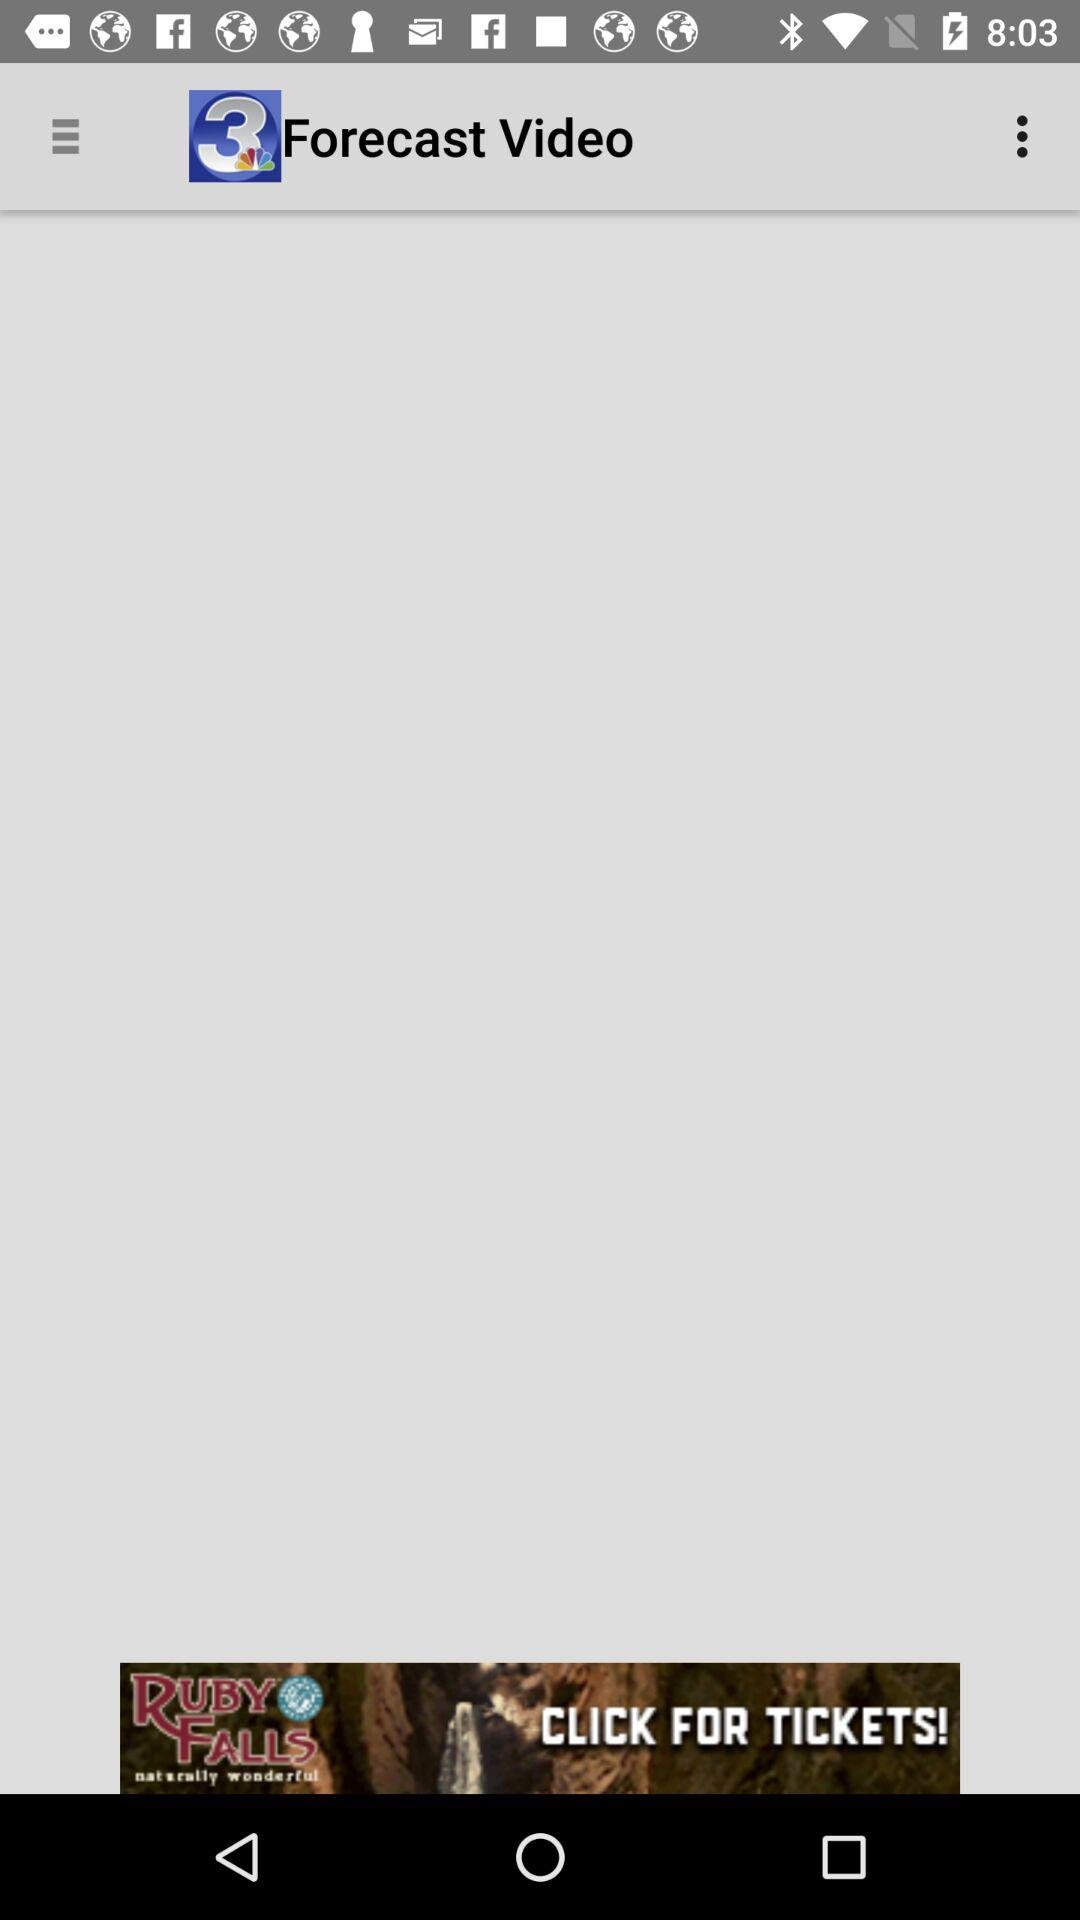What is the name of the application?
When the provided information is insufficient, respond with <no answer>. <no answer> 